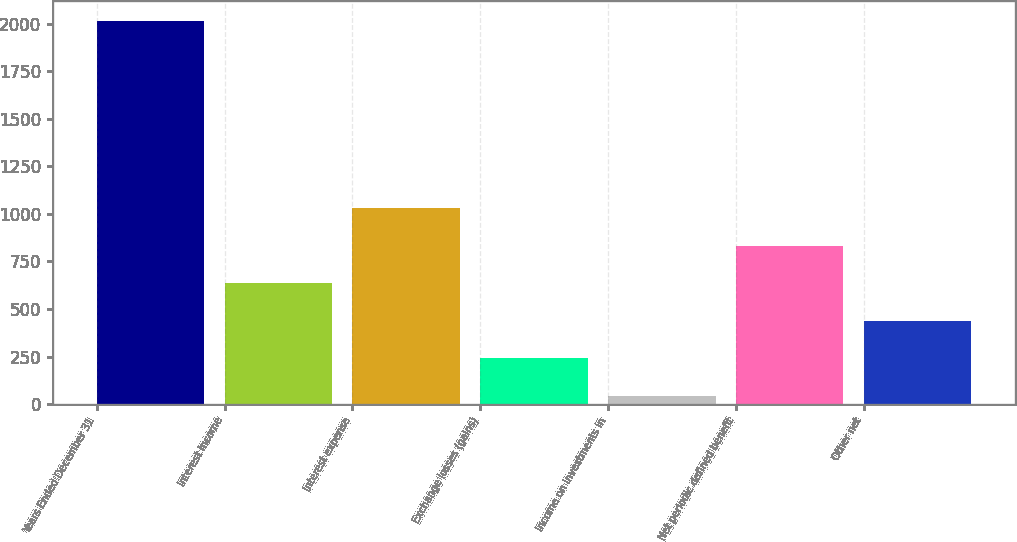<chart> <loc_0><loc_0><loc_500><loc_500><bar_chart><fcel>Years Ended December 31<fcel>Interest income<fcel>Interest expense<fcel>Exchange losses (gains)<fcel>Income on investments in<fcel>Net periodic defined benefit<fcel>Other net<nl><fcel>2016<fcel>634.9<fcel>1029.5<fcel>240.3<fcel>43<fcel>832.2<fcel>437.6<nl></chart> 